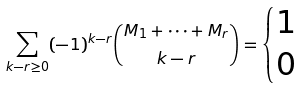<formula> <loc_0><loc_0><loc_500><loc_500>\sum _ { k - r \geq 0 } ( - 1 ) ^ { k - r } \binom { M _ { 1 } + \cdots + M _ { r } } { k - r } = \begin{cases} 1 & \\ 0 & \end{cases}</formula> 